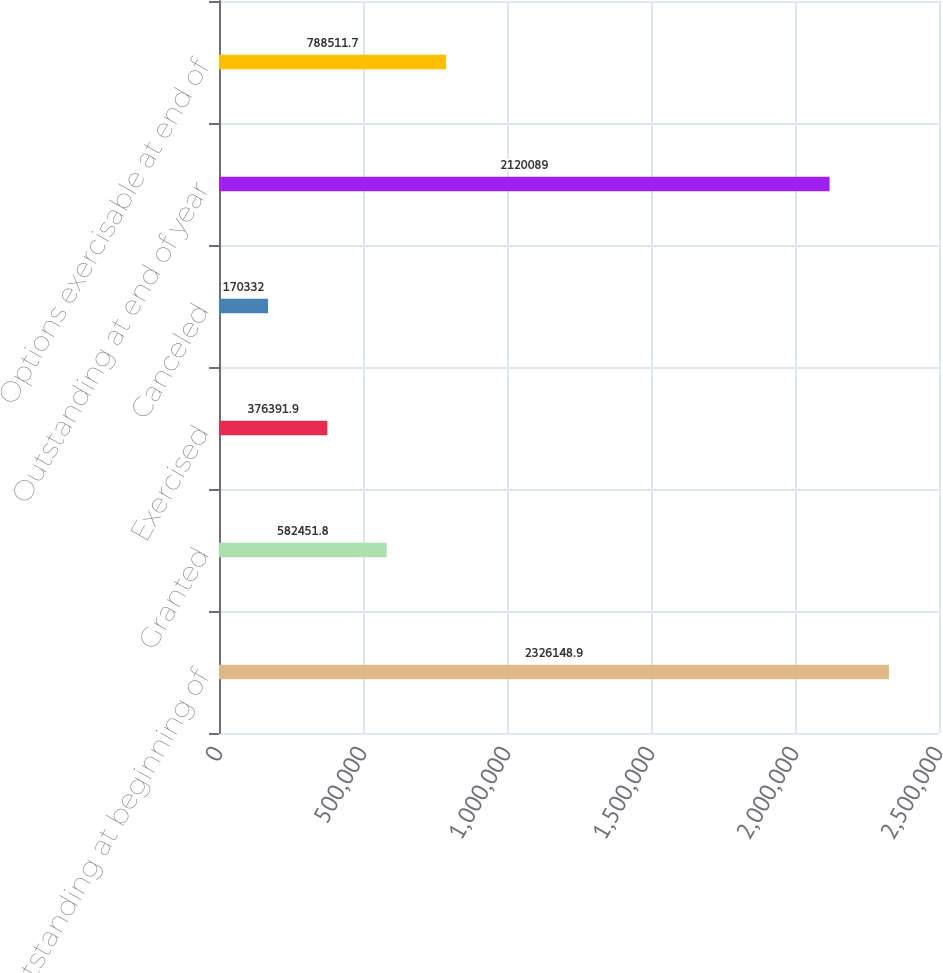Convert chart to OTSL. <chart><loc_0><loc_0><loc_500><loc_500><bar_chart><fcel>Outstanding at beginning of<fcel>Granted<fcel>Exercised<fcel>Canceled<fcel>Outstanding at end of year<fcel>Options exercisable at end of<nl><fcel>2.32615e+06<fcel>582452<fcel>376392<fcel>170332<fcel>2.12009e+06<fcel>788512<nl></chart> 